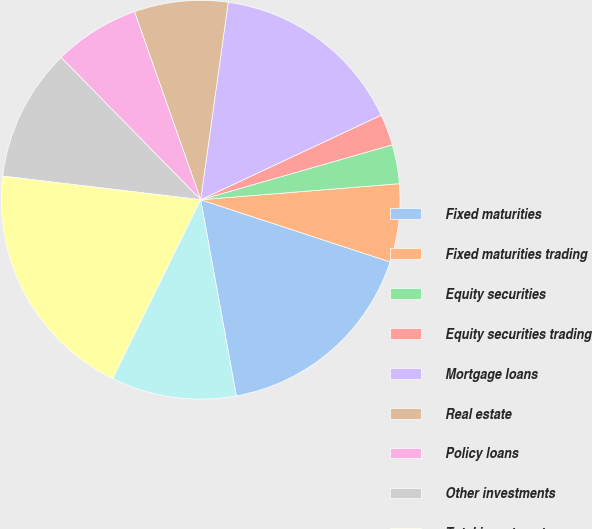<chart> <loc_0><loc_0><loc_500><loc_500><pie_chart><fcel>Fixed maturities<fcel>Fixed maturities trading<fcel>Equity securities<fcel>Equity securities trading<fcel>Mortgage loans<fcel>Real estate<fcel>Policy loans<fcel>Other investments<fcel>Total investments<fcel>Cash and cash equivalents<nl><fcel>17.09%<fcel>6.33%<fcel>3.16%<fcel>2.53%<fcel>15.82%<fcel>7.59%<fcel>6.96%<fcel>10.76%<fcel>19.62%<fcel>10.13%<nl></chart> 